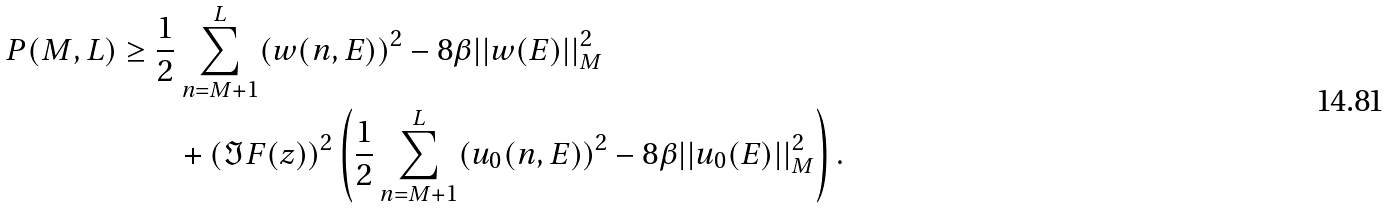Convert formula to latex. <formula><loc_0><loc_0><loc_500><loc_500>P ( M , L ) \geq \frac { 1 } { 2 } & \sum _ { n = M + 1 } ^ { L } ( w ( n , E ) ) ^ { 2 } - 8 \beta | | w ( E ) | | _ { M } ^ { 2 } \\ & + ( \Im F ( z ) ) ^ { 2 } \left ( \frac { 1 } { 2 } \sum _ { n = M + 1 } ^ { L } ( u _ { 0 } ( n , E ) ) ^ { 2 } - 8 \beta | | u _ { 0 } ( E ) | | _ { M } ^ { 2 } \right ) .</formula> 